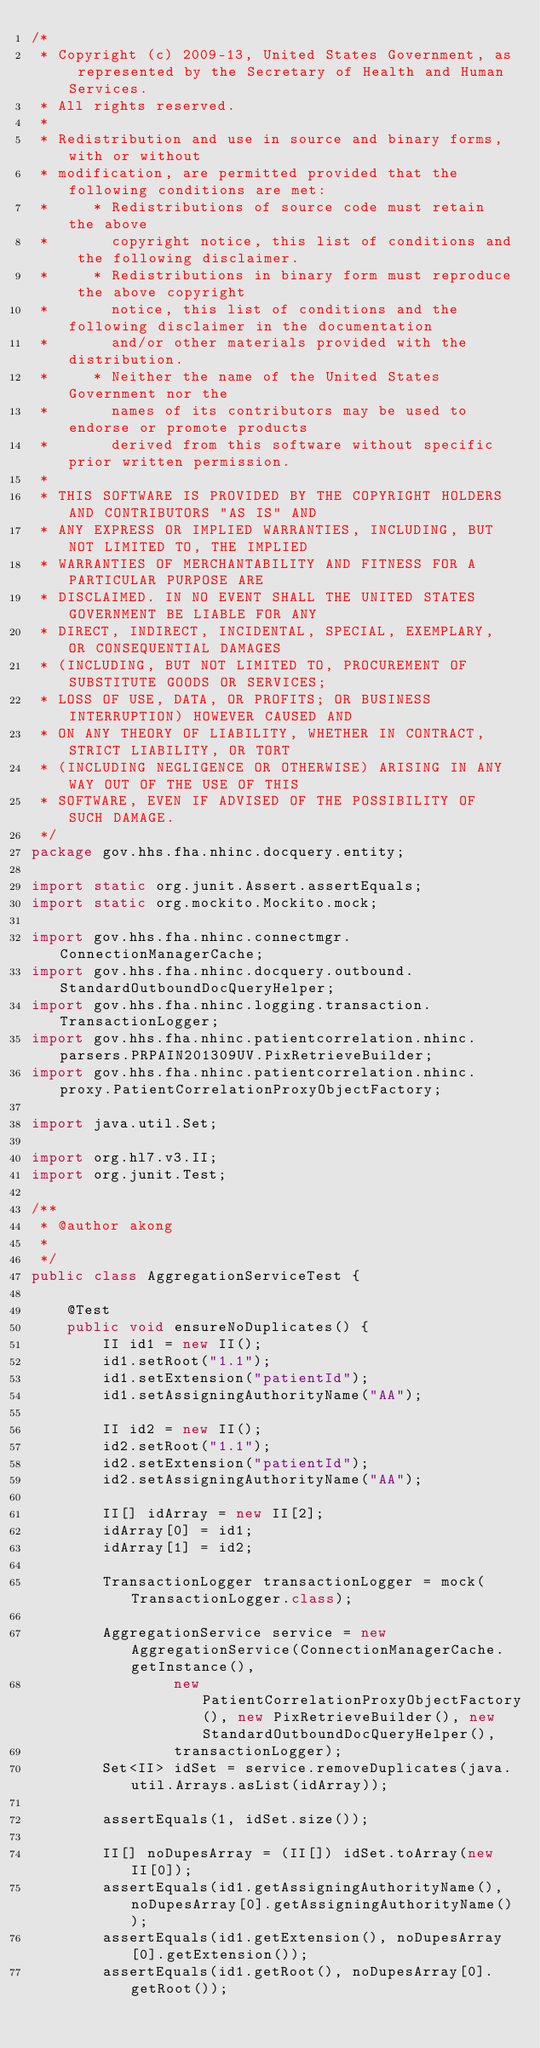Convert code to text. <code><loc_0><loc_0><loc_500><loc_500><_Java_>/*
 * Copyright (c) 2009-13, United States Government, as represented by the Secretary of Health and Human Services.
 * All rights reserved.
 *
 * Redistribution and use in source and binary forms, with or without
 * modification, are permitted provided that the following conditions are met:
 *     * Redistributions of source code must retain the above
 *       copyright notice, this list of conditions and the following disclaimer.
 *     * Redistributions in binary form must reproduce the above copyright
 *       notice, this list of conditions and the following disclaimer in the documentation
 *       and/or other materials provided with the distribution.
 *     * Neither the name of the United States Government nor the
 *       names of its contributors may be used to endorse or promote products
 *       derived from this software without specific prior written permission.
 *
 * THIS SOFTWARE IS PROVIDED BY THE COPYRIGHT HOLDERS AND CONTRIBUTORS "AS IS" AND
 * ANY EXPRESS OR IMPLIED WARRANTIES, INCLUDING, BUT NOT LIMITED TO, THE IMPLIED
 * WARRANTIES OF MERCHANTABILITY AND FITNESS FOR A PARTICULAR PURPOSE ARE
 * DISCLAIMED. IN NO EVENT SHALL THE UNITED STATES GOVERNMENT BE LIABLE FOR ANY
 * DIRECT, INDIRECT, INCIDENTAL, SPECIAL, EXEMPLARY, OR CONSEQUENTIAL DAMAGES
 * (INCLUDING, BUT NOT LIMITED TO, PROCUREMENT OF SUBSTITUTE GOODS OR SERVICES;
 * LOSS OF USE, DATA, OR PROFITS; OR BUSINESS INTERRUPTION) HOWEVER CAUSED AND
 * ON ANY THEORY OF LIABILITY, WHETHER IN CONTRACT, STRICT LIABILITY, OR TORT
 * (INCLUDING NEGLIGENCE OR OTHERWISE) ARISING IN ANY WAY OUT OF THE USE OF THIS
 * SOFTWARE, EVEN IF ADVISED OF THE POSSIBILITY OF SUCH DAMAGE.
 */
package gov.hhs.fha.nhinc.docquery.entity;

import static org.junit.Assert.assertEquals;
import static org.mockito.Mockito.mock;

import gov.hhs.fha.nhinc.connectmgr.ConnectionManagerCache;
import gov.hhs.fha.nhinc.docquery.outbound.StandardOutboundDocQueryHelper;
import gov.hhs.fha.nhinc.logging.transaction.TransactionLogger;
import gov.hhs.fha.nhinc.patientcorrelation.nhinc.parsers.PRPAIN201309UV.PixRetrieveBuilder;
import gov.hhs.fha.nhinc.patientcorrelation.nhinc.proxy.PatientCorrelationProxyObjectFactory;

import java.util.Set;

import org.hl7.v3.II;
import org.junit.Test;

/**
 * @author akong
 *
 */
public class AggregationServiceTest {
    
    @Test
    public void ensureNoDuplicates() {
        II id1 = new II();
        id1.setRoot("1.1");
        id1.setExtension("patientId");
        id1.setAssigningAuthorityName("AA");
        
        II id2 = new II();
        id2.setRoot("1.1");
        id2.setExtension("patientId");
        id2.setAssigningAuthorityName("AA");
        
        II[] idArray = new II[2];
        idArray[0] = id1;
        idArray[1] = id2;
        
        TransactionLogger transactionLogger = mock(TransactionLogger.class);
        
        AggregationService service = new AggregationService(ConnectionManagerCache.getInstance(),
                new PatientCorrelationProxyObjectFactory(), new PixRetrieveBuilder(), new StandardOutboundDocQueryHelper(),
                transactionLogger);
        Set<II> idSet = service.removeDuplicates(java.util.Arrays.asList(idArray));
        
        assertEquals(1, idSet.size());
        
        II[] noDupesArray = (II[]) idSet.toArray(new II[0]);
        assertEquals(id1.getAssigningAuthorityName(), noDupesArray[0].getAssigningAuthorityName());
        assertEquals(id1.getExtension(), noDupesArray[0].getExtension());
        assertEquals(id1.getRoot(), noDupesArray[0].getRoot());</code> 